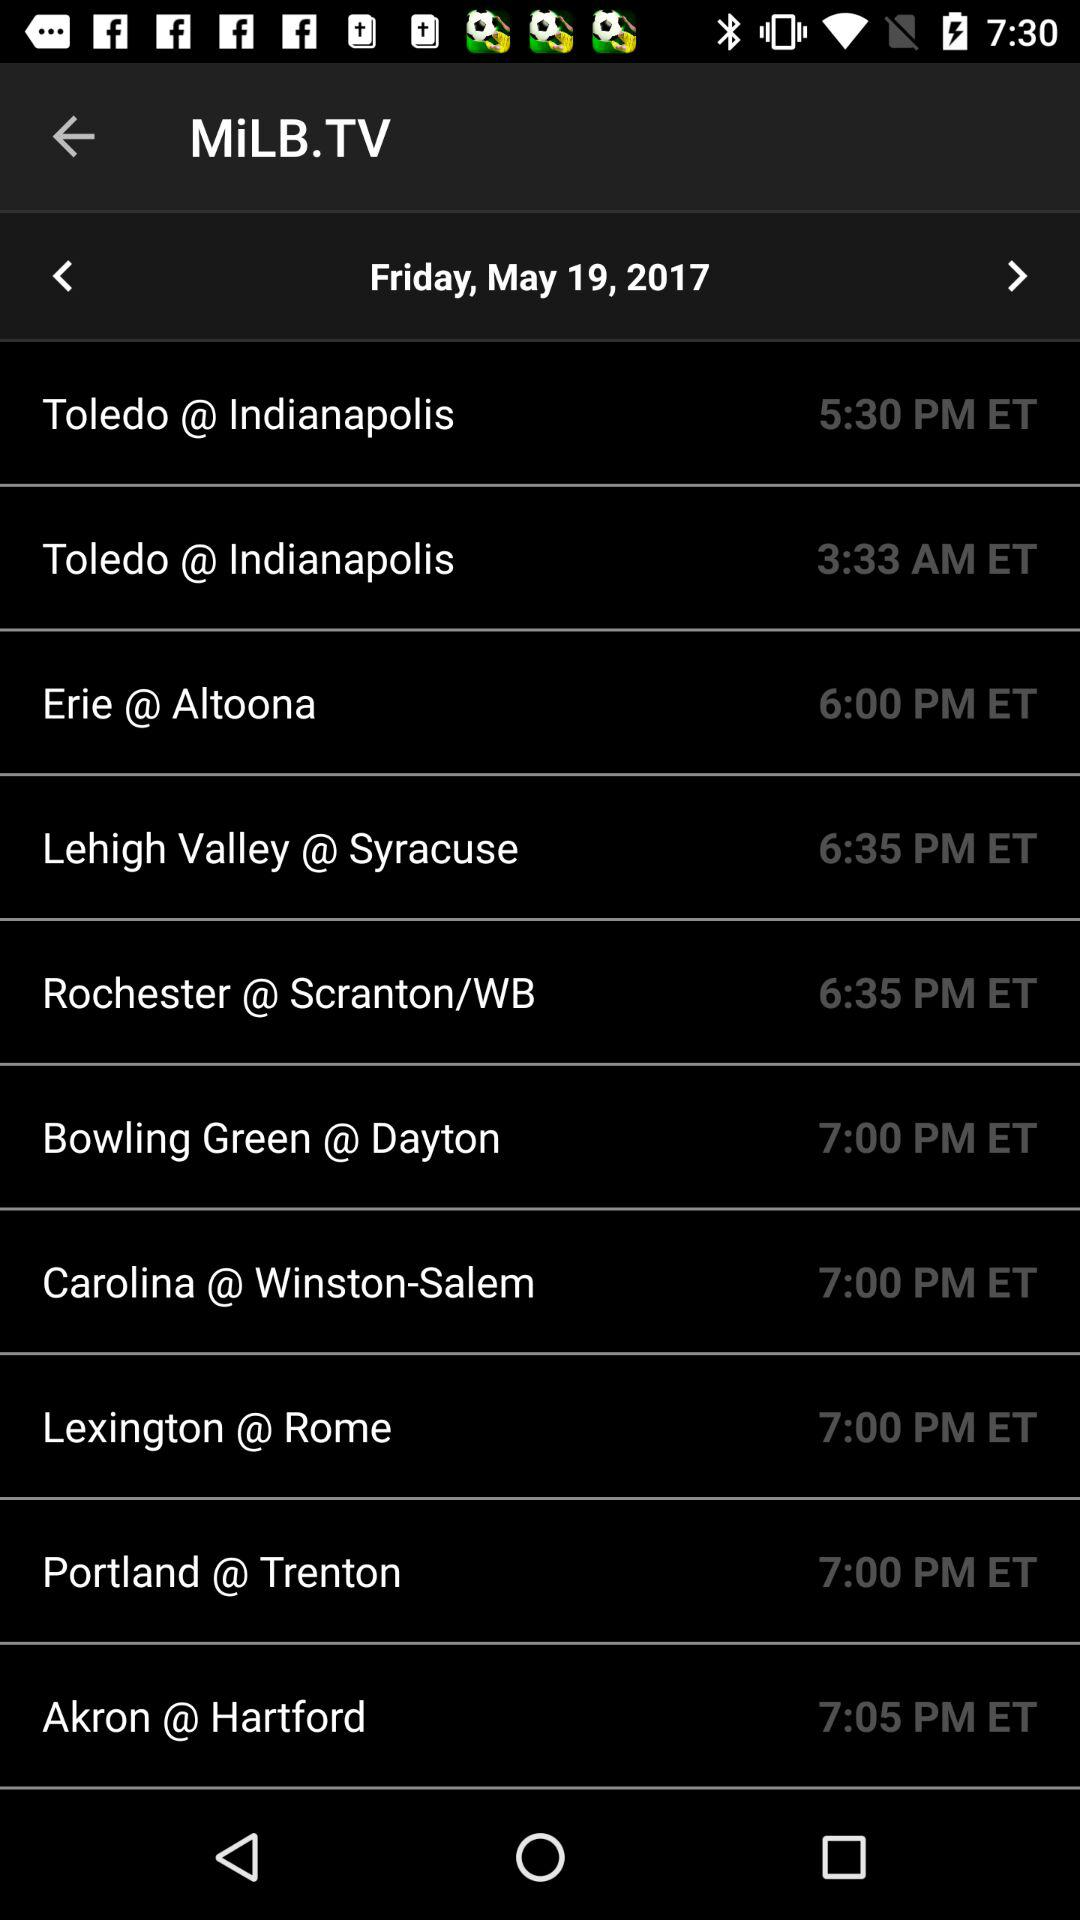What is the time in Portland? The time in Portland is 7:00 PM ET. 